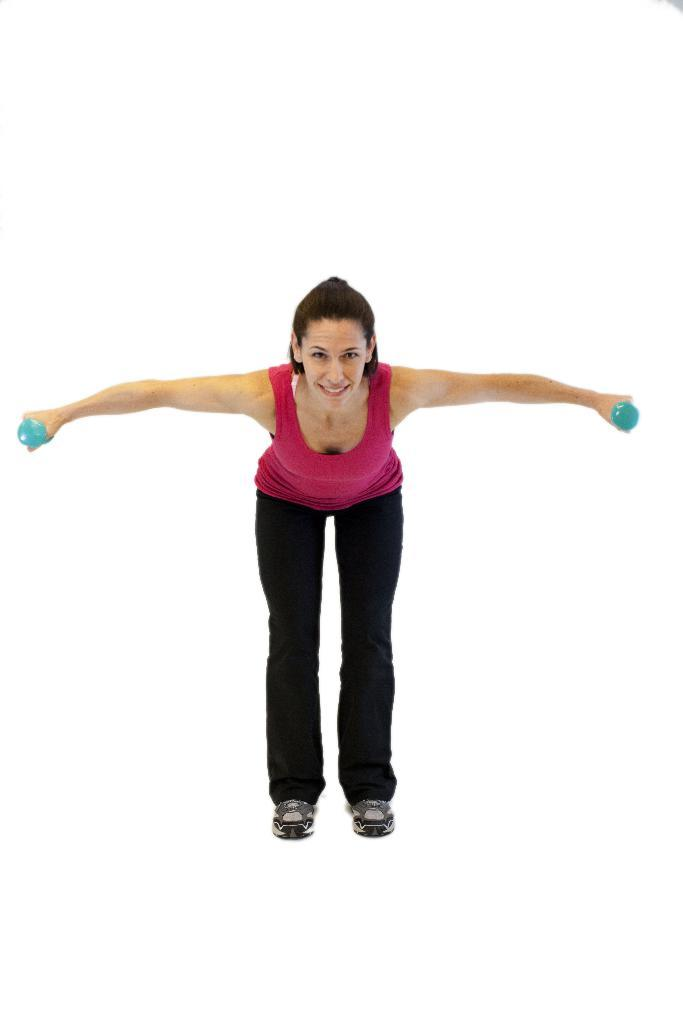Who is the main subject in the image? There is a woman in the image. What is the woman wearing? The woman is wearing black pants. What is the woman doing in the image? The woman is stretching both hands and bending on a white surface. What is the color of the surface the woman is on? The surface the woman is on is white. What is the background of the image? The background of the image is white. Can you see a rabbit playing with a maid in the image? There is no rabbit or maid present in the image. What type of appliance is the woman using in the image? There is no appliance visible in the image; the woman is simply stretching her hands and bending on a white surface. 